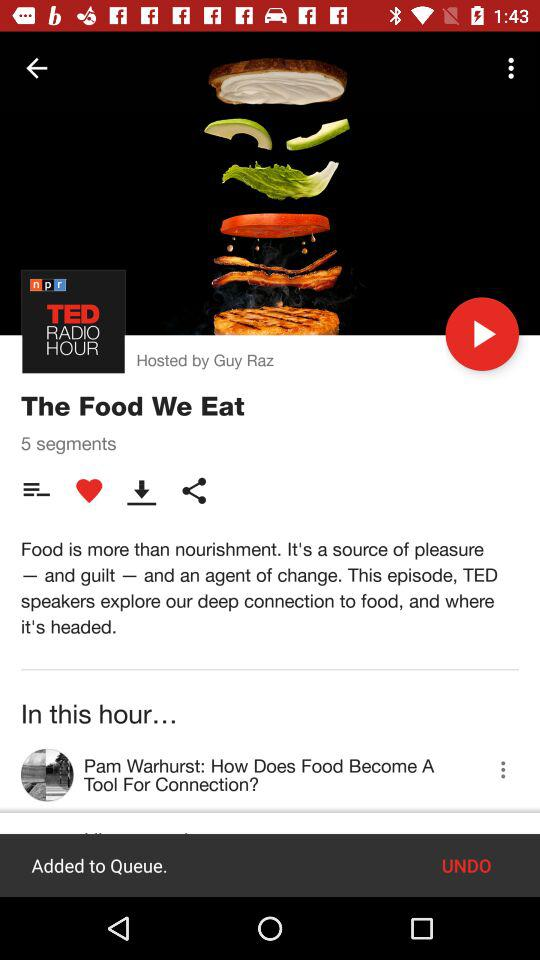How many segments are there? There are 5 segments. 